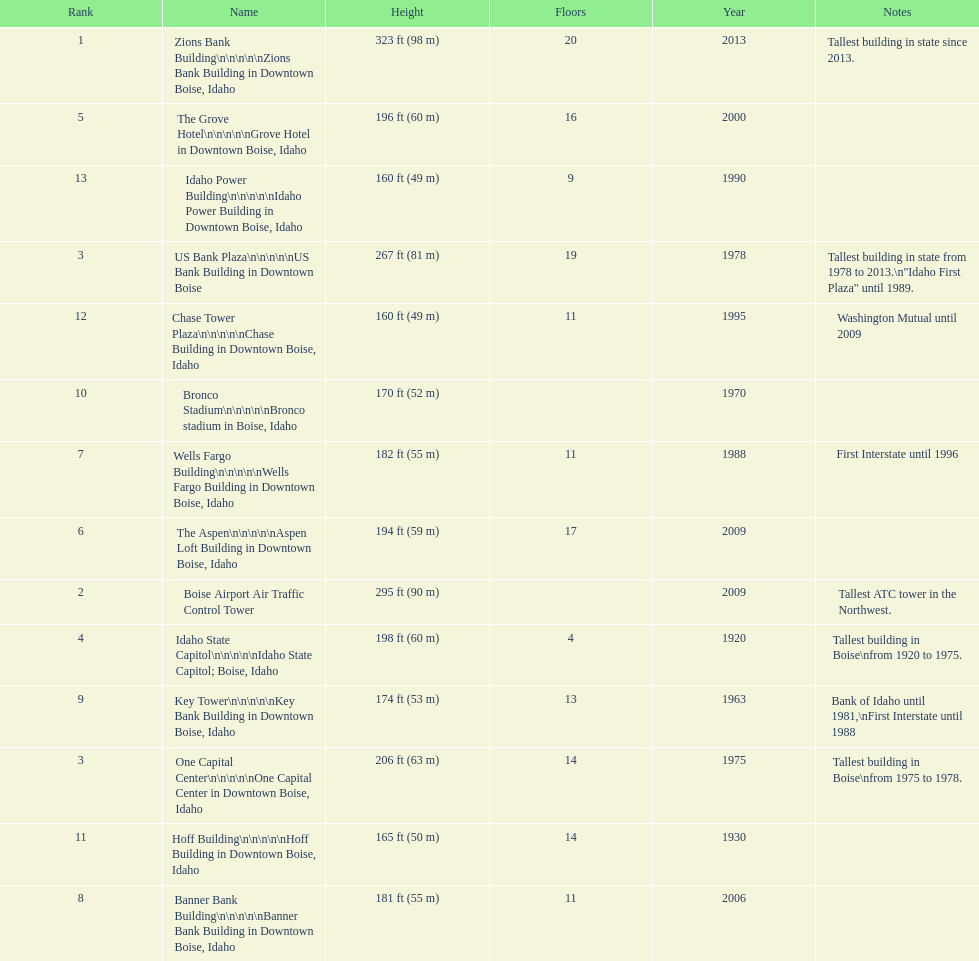How many floors does the tallest building have? 20. 